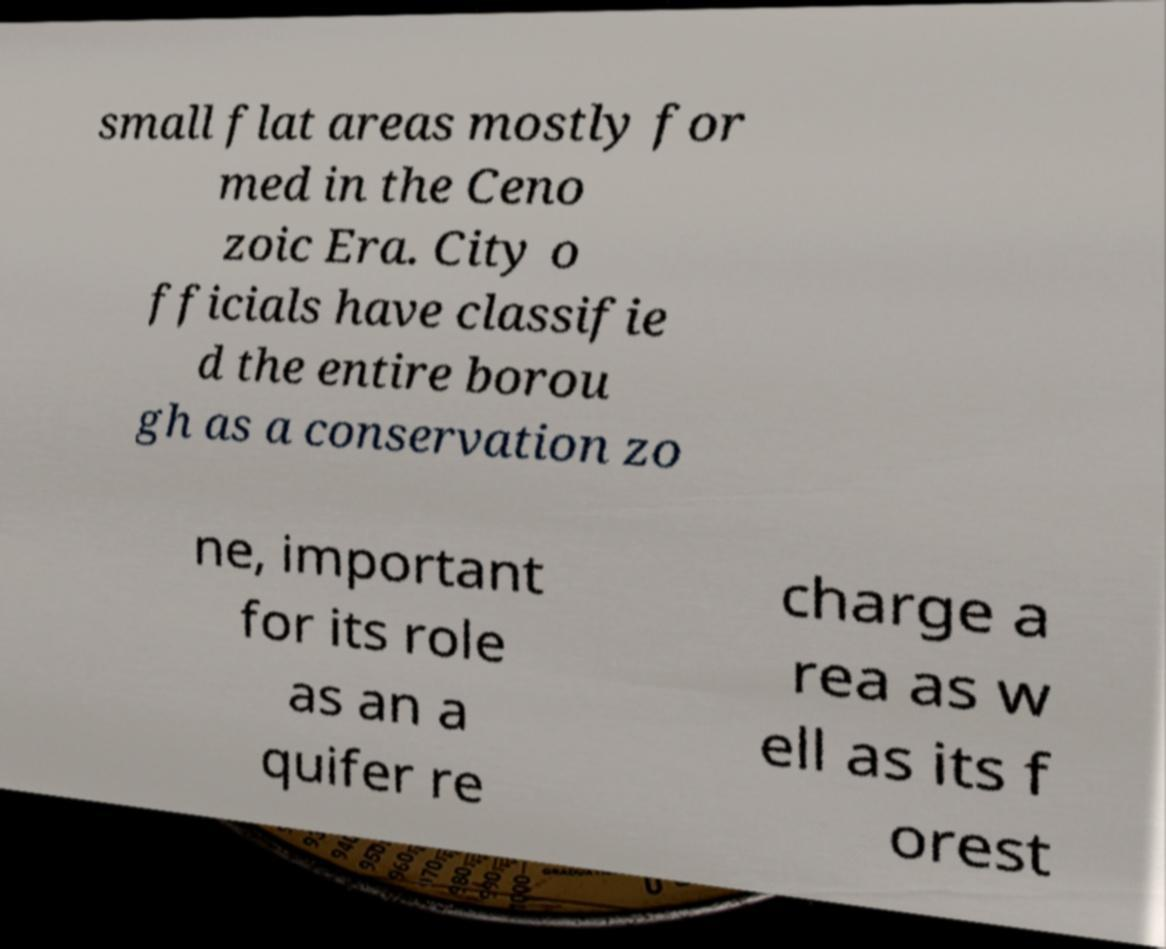What messages or text are displayed in this image? I need them in a readable, typed format. small flat areas mostly for med in the Ceno zoic Era. City o fficials have classifie d the entire borou gh as a conservation zo ne, important for its role as an a quifer re charge a rea as w ell as its f orest 